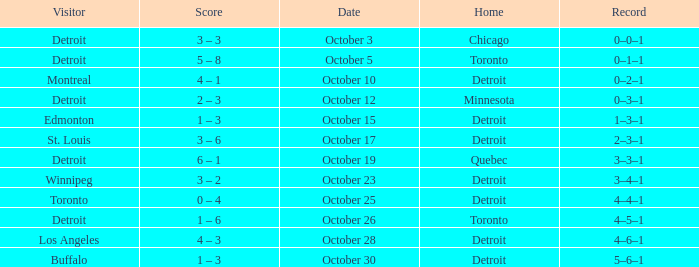Name the home with toronto visiting Detroit. 